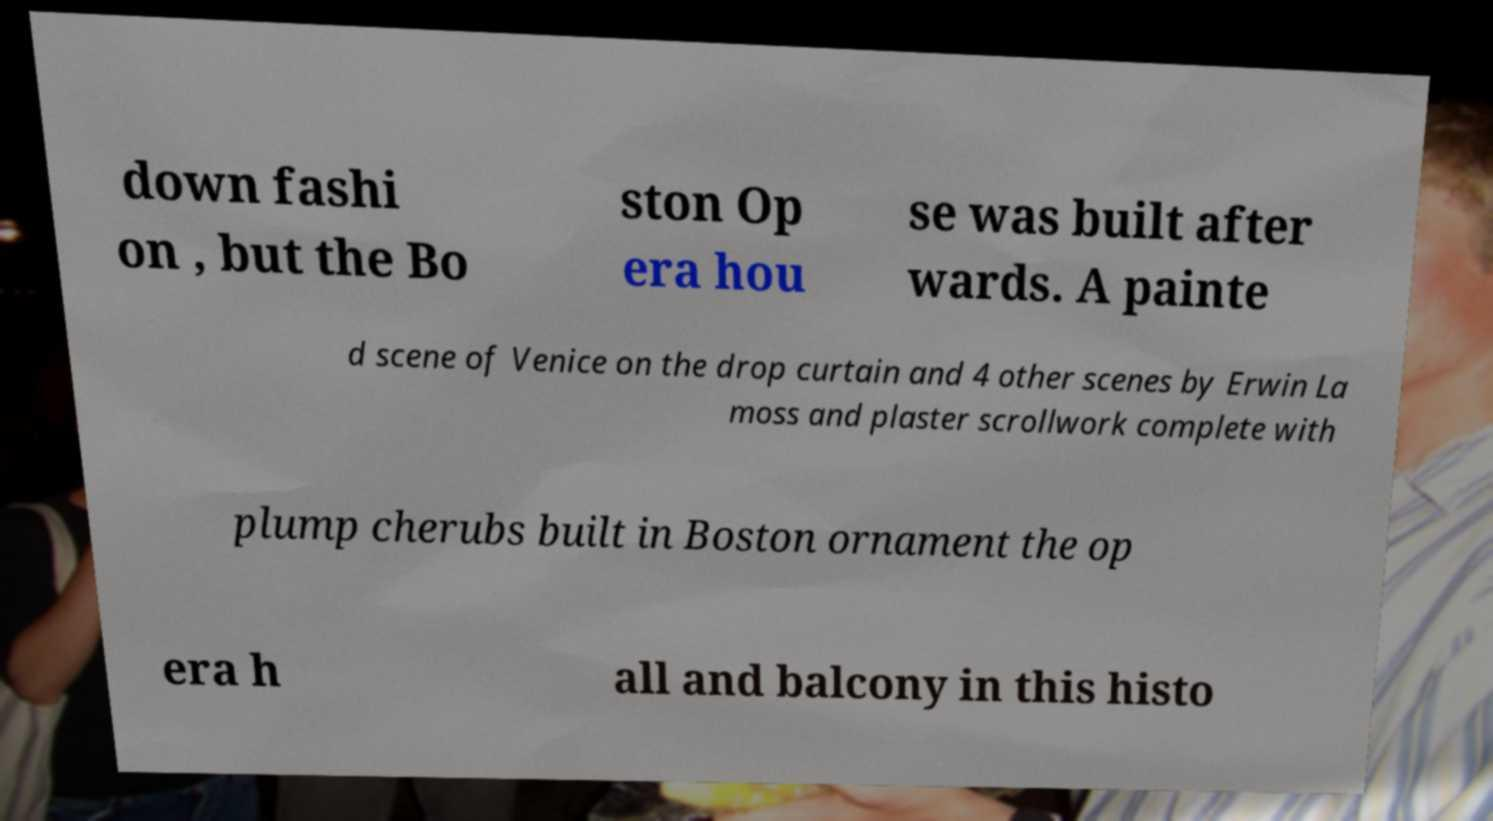I need the written content from this picture converted into text. Can you do that? down fashi on , but the Bo ston Op era hou se was built after wards. A painte d scene of Venice on the drop curtain and 4 other scenes by Erwin La moss and plaster scrollwork complete with plump cherubs built in Boston ornament the op era h all and balcony in this histo 